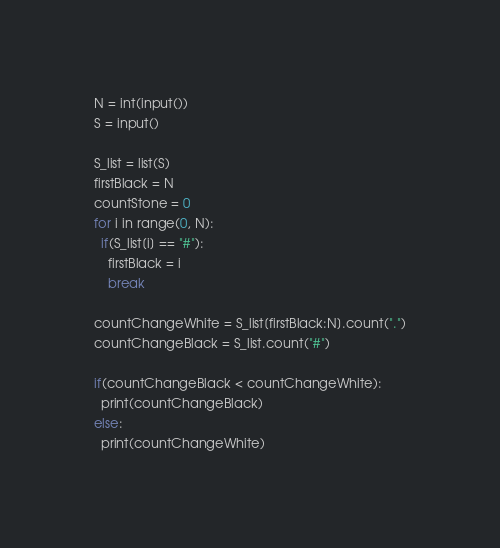Convert code to text. <code><loc_0><loc_0><loc_500><loc_500><_Python_>N = int(input())
S = input()

S_list = list(S)
firstBlack = N
countStone = 0
for i in range(0, N):
  if(S_list[i] == "#"):
    firstBlack = i
    break

countChangeWhite = S_list[firstBlack:N].count(".")
countChangeBlack = S_list.count("#")

if(countChangeBlack < countChangeWhite):
  print(countChangeBlack)
else:
  print(countChangeWhite)</code> 